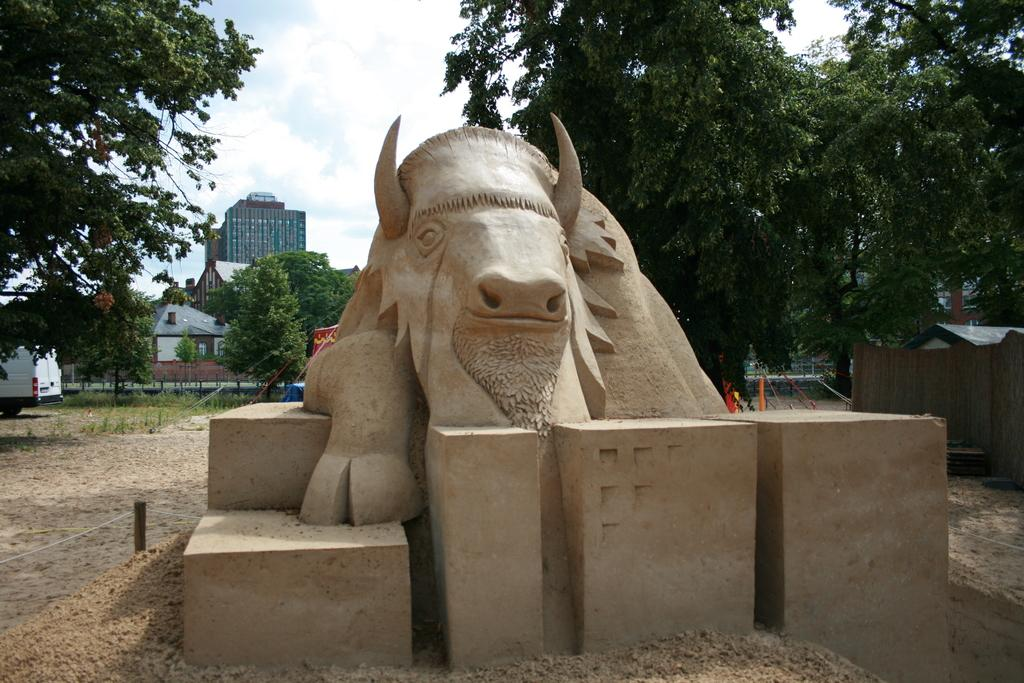What type of animal is depicted as a statue in the image? The image contains a statue of an animal, but the specific animal cannot be determined from the provided facts. What can be seen on the ground in the image? The ground is visible in the image, but no specific details about the ground can be determined from the provided facts. What are the poles in the image used for? The purpose of the poles in the image cannot be determined from the provided facts. What are the wires connected to in the image? The wires in the image are connected to the poles, but their specific purpose cannot be determined from the provided facts. What type of trees are present in the image? The type of trees in the image cannot be determined from the provided facts. What type of plants are visible in the image? The type of plants in the image cannot be determined from the provided facts. What type of grass is present in the image? The type of grass in the image cannot be determined from the provided facts. What type of buildings are visible in the image? The type of buildings in the image cannot be determined from the provided facts. What type of houses are visible in the image? The type of houses in the image cannot be determined from the provided facts. What type of vehicles are present in the image? The type of vehicles in the image cannot be determined from the provided facts. What is the color of the sky in the image? The color of the sky in the image cannot be determined from the provided facts. What type of clouds are present in the sky? The type of clouds in the sky cannot be determined from the provided facts. How many giants are holding the wires in the image? There are no giants present in the image; the wires are connected to poles. What type of engine is visible in the image? There is no engine present in the image. What type of cord is used to connect the statue to the ground in the image? There is no cord connecting the statue to the ground in the image. 